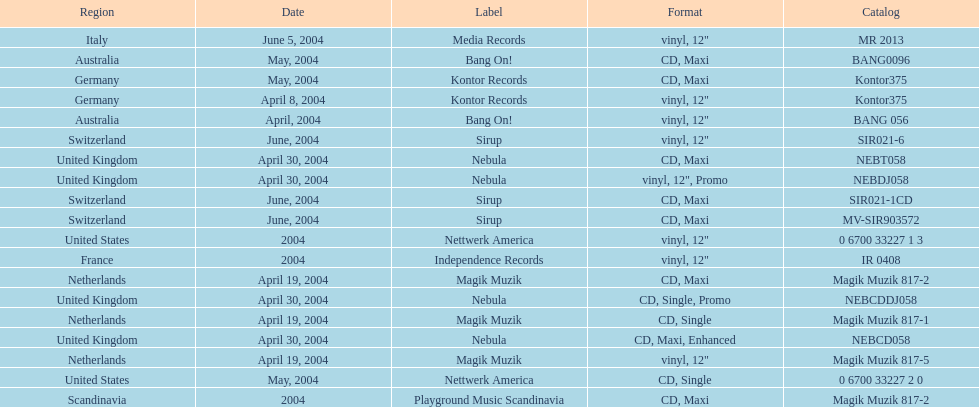What region was on the label sirup? Switzerland. 